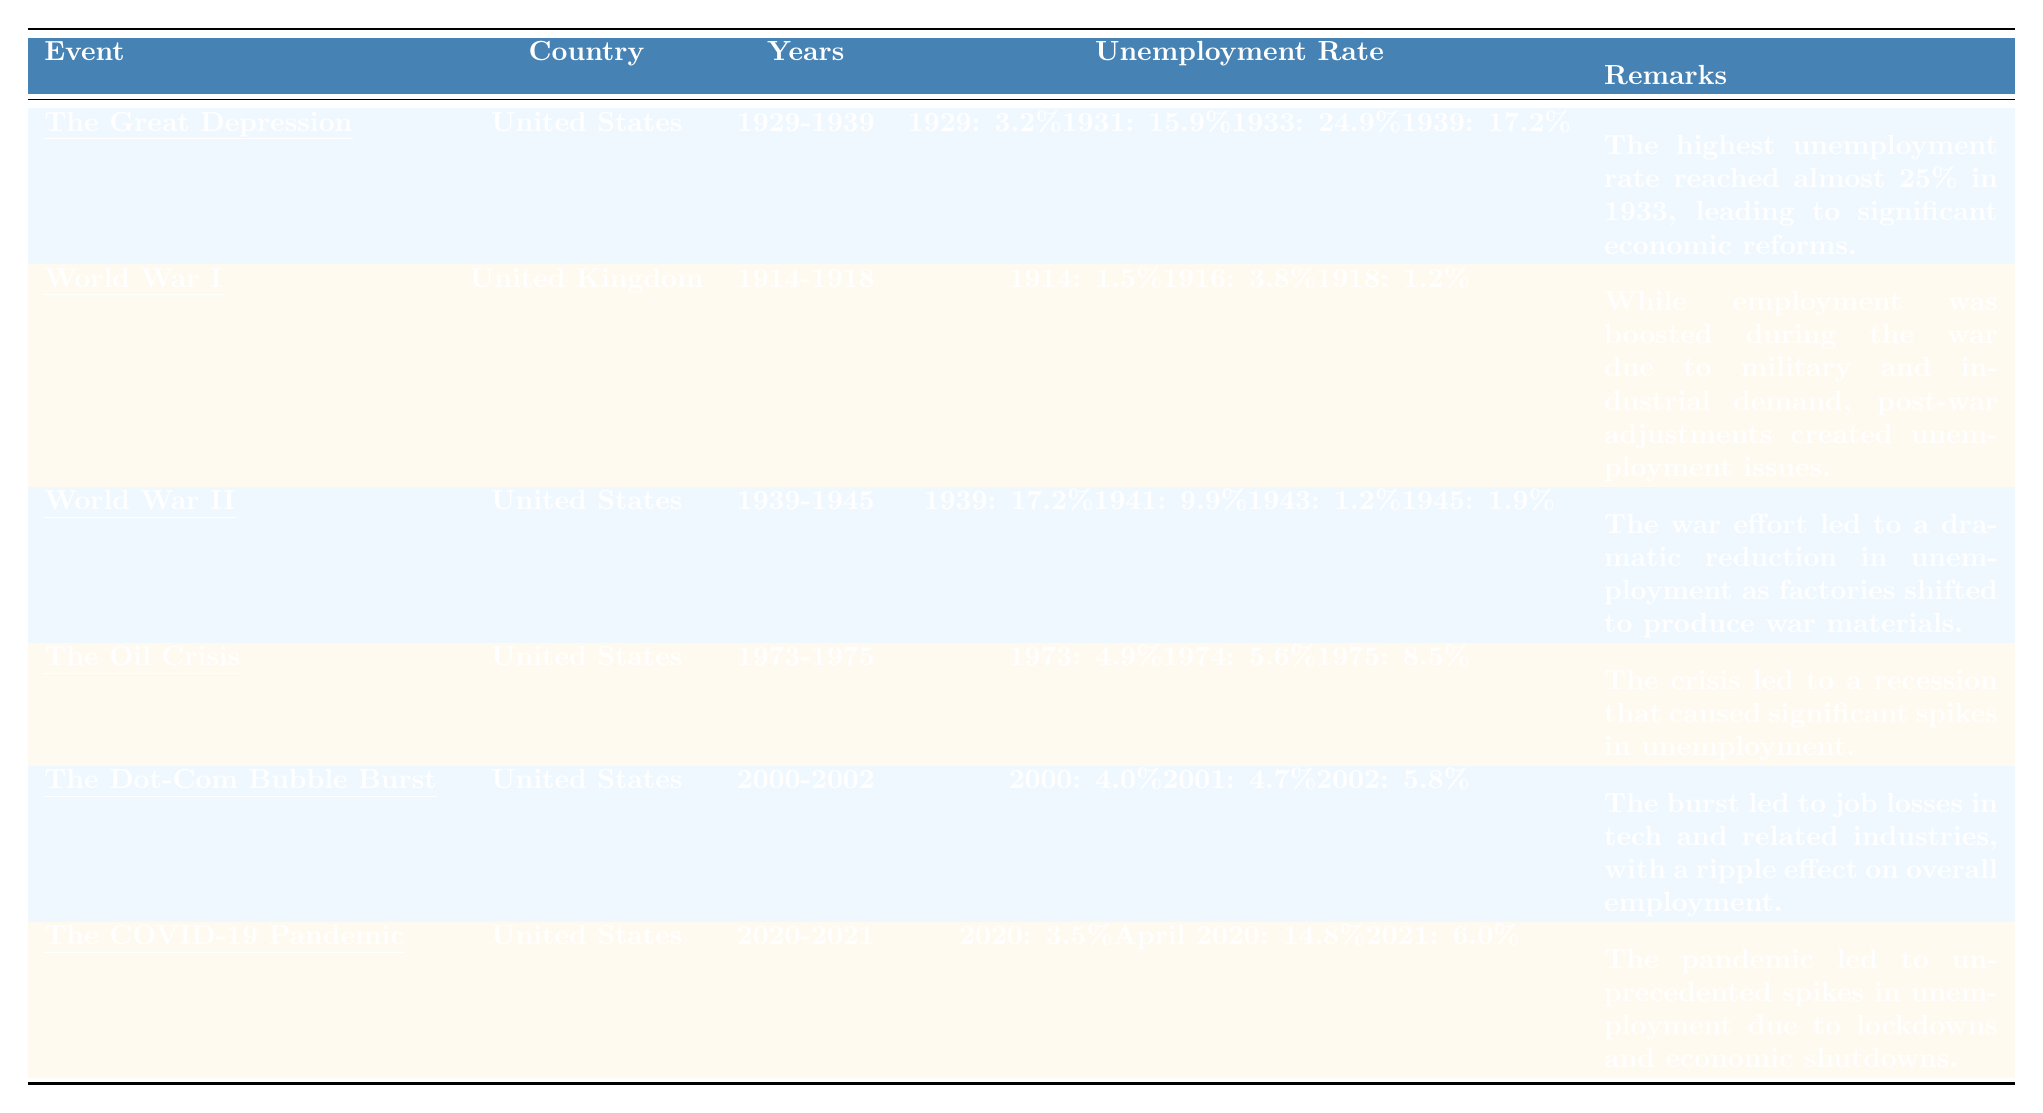What was the highest unemployment rate during the Great Depression? The table indicates that the highest unemployment rate during the Great Depression was 24.9% in 1933.
Answer: 24.9% Which country experienced a fall in unemployment from 1941 to 1943 during World War II? According to the table, the United States saw a significant decrease in unemployment from 9.9% in 1941 to 1.2% in 1943 during World War II.
Answer: United States What was the unemployment rate in the United Kingdom during World War I in 1914? The table shows that the unemployment rate in the United Kingdom in 1914 was 1.5%.
Answer: 1.5% What was the average unemployment rate in the United States during World War II? The unemployment rates during World War II for the United States were 17.2% (1939), 9.9% (1941), 1.2% (1943), and 1.9% (1945). The average is calculated as (17.2 + 9.9 + 1.2 + 1.9) / 4 = 7.55%.
Answer: 7.55% Did the unemployment rate in the United States rise or fall from 1973 to 1975 during the Oil Crisis? The table shows an increase in unemployment in the United States from 4.9% in 1973 to 8.5% in 1975 during the Oil Crisis, indicating a rise.
Answer: Rise What event led to the highest unemployment rate of nearly 25% in a specific year? The data indicates that the Great Depression saw the highest unemployment rate of nearly 25% in 1933.
Answer: Great Depression Between which two years did the United States see a dramatic reduction in unemployment due to the war effort? Based on the table, the United States saw a significant reduction in unemployment from 1941 (9.9%) to 1943 (1.2%) during World War II.
Answer: 1941 to 1943 Was the unemployment rate during the COVID-19 pandemic higher or lower in 2021 compared to 2020? The table shows that unemployment in 2021 was 6.0%, which is higher than the rate of 3.5% in 2020. Therefore, it was lower in 2020.
Answer: Lower in 2020 What was the unemployment trend in the United States from 2000 to 2002 following the Dot-Com bubble burst? The table shows a rise in the unemployment rate from 4.0% in 2000 to 5.8% in 2002, indicating a trend of increasing unemployment.
Answer: Increasing unemployment What were the unemployment rates in the United States for 1974 and 1975 during the Oil Crisis? The unemployment rates in the United States during the Oil Crisis were 5.6% in 1974 and 8.5% in 1975, as indicated in the table.
Answer: 5.6% in 1974 and 8.5% in 1975 